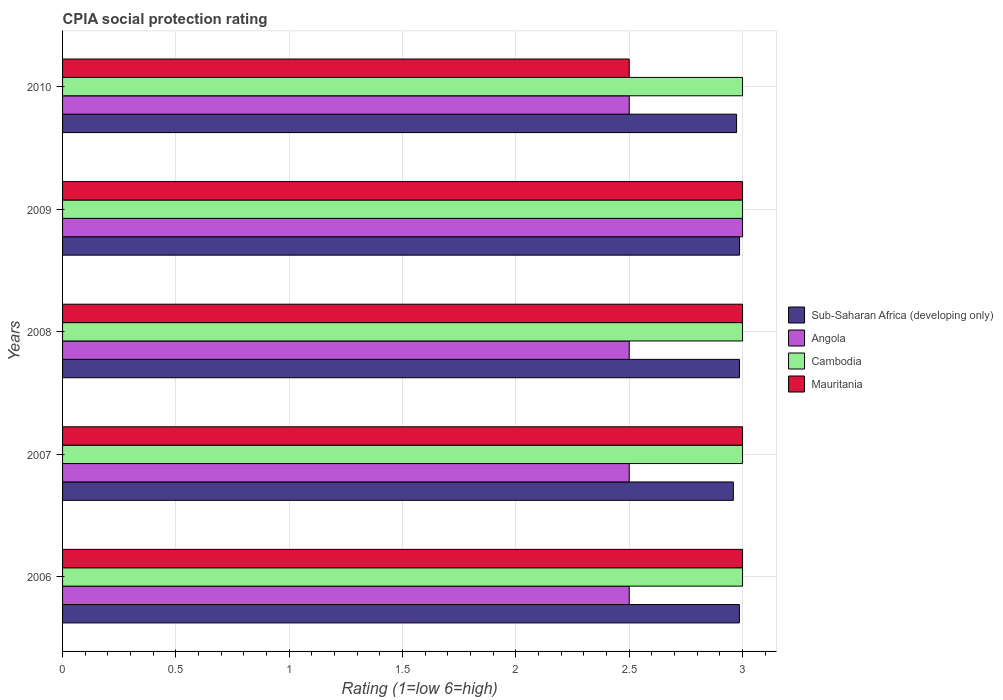Are the number of bars per tick equal to the number of legend labels?
Your answer should be compact. Yes. Are the number of bars on each tick of the Y-axis equal?
Offer a terse response. Yes. How many bars are there on the 2nd tick from the top?
Provide a succinct answer. 4. How many bars are there on the 1st tick from the bottom?
Provide a short and direct response. 4. What is the label of the 2nd group of bars from the top?
Give a very brief answer. 2009. Across all years, what is the maximum CPIA rating in Cambodia?
Your response must be concise. 3. In which year was the CPIA rating in Angola maximum?
Your answer should be compact. 2009. In which year was the CPIA rating in Mauritania minimum?
Your response must be concise. 2010. What is the total CPIA rating in Cambodia in the graph?
Provide a succinct answer. 15. What is the difference between the CPIA rating in Mauritania in 2010 and the CPIA rating in Angola in 2008?
Keep it short and to the point. 0. What is the average CPIA rating in Mauritania per year?
Offer a very short reply. 2.9. In the year 2010, what is the difference between the CPIA rating in Mauritania and CPIA rating in Sub-Saharan Africa (developing only)?
Ensure brevity in your answer.  -0.47. In how many years, is the CPIA rating in Angola greater than 0.6 ?
Offer a terse response. 5. What is the ratio of the CPIA rating in Mauritania in 2006 to that in 2009?
Make the answer very short. 1. Is the difference between the CPIA rating in Mauritania in 2007 and 2009 greater than the difference between the CPIA rating in Sub-Saharan Africa (developing only) in 2007 and 2009?
Provide a succinct answer. Yes. What is the difference between the highest and the second highest CPIA rating in Sub-Saharan Africa (developing only)?
Ensure brevity in your answer.  0. What is the difference between the highest and the lowest CPIA rating in Sub-Saharan Africa (developing only)?
Offer a terse response. 0.03. What does the 1st bar from the top in 2010 represents?
Provide a succinct answer. Mauritania. What does the 2nd bar from the bottom in 2008 represents?
Offer a terse response. Angola. How many bars are there?
Your answer should be compact. 20. Are all the bars in the graph horizontal?
Provide a short and direct response. Yes. Does the graph contain any zero values?
Provide a short and direct response. No. Does the graph contain grids?
Make the answer very short. Yes. Where does the legend appear in the graph?
Give a very brief answer. Center right. What is the title of the graph?
Give a very brief answer. CPIA social protection rating. Does "Uganda" appear as one of the legend labels in the graph?
Offer a very short reply. No. What is the label or title of the X-axis?
Make the answer very short. Rating (1=low 6=high). What is the label or title of the Y-axis?
Offer a terse response. Years. What is the Rating (1=low 6=high) of Sub-Saharan Africa (developing only) in 2006?
Your answer should be very brief. 2.99. What is the Rating (1=low 6=high) in Angola in 2006?
Provide a short and direct response. 2.5. What is the Rating (1=low 6=high) of Sub-Saharan Africa (developing only) in 2007?
Your answer should be compact. 2.96. What is the Rating (1=low 6=high) of Angola in 2007?
Provide a short and direct response. 2.5. What is the Rating (1=low 6=high) in Cambodia in 2007?
Offer a very short reply. 3. What is the Rating (1=low 6=high) of Mauritania in 2007?
Keep it short and to the point. 3. What is the Rating (1=low 6=high) in Sub-Saharan Africa (developing only) in 2008?
Your answer should be very brief. 2.99. What is the Rating (1=low 6=high) of Cambodia in 2008?
Provide a succinct answer. 3. What is the Rating (1=low 6=high) of Mauritania in 2008?
Give a very brief answer. 3. What is the Rating (1=low 6=high) of Sub-Saharan Africa (developing only) in 2009?
Your response must be concise. 2.99. What is the Rating (1=low 6=high) in Angola in 2009?
Your answer should be very brief. 3. What is the Rating (1=low 6=high) in Cambodia in 2009?
Ensure brevity in your answer.  3. What is the Rating (1=low 6=high) of Sub-Saharan Africa (developing only) in 2010?
Your answer should be very brief. 2.97. What is the Rating (1=low 6=high) of Angola in 2010?
Ensure brevity in your answer.  2.5. What is the Rating (1=low 6=high) of Cambodia in 2010?
Ensure brevity in your answer.  3. What is the Rating (1=low 6=high) of Mauritania in 2010?
Provide a succinct answer. 2.5. Across all years, what is the maximum Rating (1=low 6=high) of Sub-Saharan Africa (developing only)?
Offer a very short reply. 2.99. Across all years, what is the maximum Rating (1=low 6=high) of Angola?
Your response must be concise. 3. Across all years, what is the maximum Rating (1=low 6=high) in Cambodia?
Give a very brief answer. 3. Across all years, what is the maximum Rating (1=low 6=high) of Mauritania?
Keep it short and to the point. 3. Across all years, what is the minimum Rating (1=low 6=high) of Sub-Saharan Africa (developing only)?
Provide a succinct answer. 2.96. Across all years, what is the minimum Rating (1=low 6=high) of Cambodia?
Your answer should be very brief. 3. What is the total Rating (1=low 6=high) in Sub-Saharan Africa (developing only) in the graph?
Make the answer very short. 14.89. What is the total Rating (1=low 6=high) in Mauritania in the graph?
Your answer should be compact. 14.5. What is the difference between the Rating (1=low 6=high) of Sub-Saharan Africa (developing only) in 2006 and that in 2007?
Your answer should be compact. 0.03. What is the difference between the Rating (1=low 6=high) of Cambodia in 2006 and that in 2007?
Make the answer very short. 0. What is the difference between the Rating (1=low 6=high) in Sub-Saharan Africa (developing only) in 2006 and that in 2008?
Provide a succinct answer. -0. What is the difference between the Rating (1=low 6=high) of Sub-Saharan Africa (developing only) in 2006 and that in 2009?
Ensure brevity in your answer.  -0. What is the difference between the Rating (1=low 6=high) in Angola in 2006 and that in 2009?
Offer a terse response. -0.5. What is the difference between the Rating (1=low 6=high) in Sub-Saharan Africa (developing only) in 2006 and that in 2010?
Give a very brief answer. 0.01. What is the difference between the Rating (1=low 6=high) of Sub-Saharan Africa (developing only) in 2007 and that in 2008?
Keep it short and to the point. -0.03. What is the difference between the Rating (1=low 6=high) of Angola in 2007 and that in 2008?
Your answer should be very brief. 0. What is the difference between the Rating (1=low 6=high) in Sub-Saharan Africa (developing only) in 2007 and that in 2009?
Provide a short and direct response. -0.03. What is the difference between the Rating (1=low 6=high) of Angola in 2007 and that in 2009?
Give a very brief answer. -0.5. What is the difference between the Rating (1=low 6=high) of Cambodia in 2007 and that in 2009?
Provide a succinct answer. 0. What is the difference between the Rating (1=low 6=high) of Sub-Saharan Africa (developing only) in 2007 and that in 2010?
Keep it short and to the point. -0.01. What is the difference between the Rating (1=low 6=high) in Angola in 2007 and that in 2010?
Offer a very short reply. 0. What is the difference between the Rating (1=low 6=high) in Sub-Saharan Africa (developing only) in 2008 and that in 2009?
Give a very brief answer. -0. What is the difference between the Rating (1=low 6=high) of Cambodia in 2008 and that in 2009?
Provide a succinct answer. 0. What is the difference between the Rating (1=low 6=high) of Mauritania in 2008 and that in 2009?
Ensure brevity in your answer.  0. What is the difference between the Rating (1=low 6=high) of Sub-Saharan Africa (developing only) in 2008 and that in 2010?
Offer a very short reply. 0.01. What is the difference between the Rating (1=low 6=high) of Angola in 2008 and that in 2010?
Offer a terse response. 0. What is the difference between the Rating (1=low 6=high) in Cambodia in 2008 and that in 2010?
Offer a terse response. 0. What is the difference between the Rating (1=low 6=high) of Sub-Saharan Africa (developing only) in 2009 and that in 2010?
Your answer should be very brief. 0.01. What is the difference between the Rating (1=low 6=high) of Cambodia in 2009 and that in 2010?
Your answer should be compact. 0. What is the difference between the Rating (1=low 6=high) of Mauritania in 2009 and that in 2010?
Keep it short and to the point. 0.5. What is the difference between the Rating (1=low 6=high) in Sub-Saharan Africa (developing only) in 2006 and the Rating (1=low 6=high) in Angola in 2007?
Make the answer very short. 0.49. What is the difference between the Rating (1=low 6=high) in Sub-Saharan Africa (developing only) in 2006 and the Rating (1=low 6=high) in Cambodia in 2007?
Keep it short and to the point. -0.01. What is the difference between the Rating (1=low 6=high) of Sub-Saharan Africa (developing only) in 2006 and the Rating (1=low 6=high) of Mauritania in 2007?
Provide a short and direct response. -0.01. What is the difference between the Rating (1=low 6=high) in Angola in 2006 and the Rating (1=low 6=high) in Cambodia in 2007?
Ensure brevity in your answer.  -0.5. What is the difference between the Rating (1=low 6=high) of Sub-Saharan Africa (developing only) in 2006 and the Rating (1=low 6=high) of Angola in 2008?
Your answer should be very brief. 0.49. What is the difference between the Rating (1=low 6=high) of Sub-Saharan Africa (developing only) in 2006 and the Rating (1=low 6=high) of Cambodia in 2008?
Offer a very short reply. -0.01. What is the difference between the Rating (1=low 6=high) of Sub-Saharan Africa (developing only) in 2006 and the Rating (1=low 6=high) of Mauritania in 2008?
Provide a short and direct response. -0.01. What is the difference between the Rating (1=low 6=high) in Angola in 2006 and the Rating (1=low 6=high) in Cambodia in 2008?
Offer a terse response. -0.5. What is the difference between the Rating (1=low 6=high) in Angola in 2006 and the Rating (1=low 6=high) in Mauritania in 2008?
Give a very brief answer. -0.5. What is the difference between the Rating (1=low 6=high) of Cambodia in 2006 and the Rating (1=low 6=high) of Mauritania in 2008?
Your response must be concise. 0. What is the difference between the Rating (1=low 6=high) in Sub-Saharan Africa (developing only) in 2006 and the Rating (1=low 6=high) in Angola in 2009?
Provide a succinct answer. -0.01. What is the difference between the Rating (1=low 6=high) in Sub-Saharan Africa (developing only) in 2006 and the Rating (1=low 6=high) in Cambodia in 2009?
Keep it short and to the point. -0.01. What is the difference between the Rating (1=low 6=high) in Sub-Saharan Africa (developing only) in 2006 and the Rating (1=low 6=high) in Mauritania in 2009?
Provide a short and direct response. -0.01. What is the difference between the Rating (1=low 6=high) in Angola in 2006 and the Rating (1=low 6=high) in Cambodia in 2009?
Your answer should be compact. -0.5. What is the difference between the Rating (1=low 6=high) of Sub-Saharan Africa (developing only) in 2006 and the Rating (1=low 6=high) of Angola in 2010?
Give a very brief answer. 0.49. What is the difference between the Rating (1=low 6=high) of Sub-Saharan Africa (developing only) in 2006 and the Rating (1=low 6=high) of Cambodia in 2010?
Provide a succinct answer. -0.01. What is the difference between the Rating (1=low 6=high) of Sub-Saharan Africa (developing only) in 2006 and the Rating (1=low 6=high) of Mauritania in 2010?
Offer a terse response. 0.49. What is the difference between the Rating (1=low 6=high) in Angola in 2006 and the Rating (1=low 6=high) in Mauritania in 2010?
Offer a very short reply. 0. What is the difference between the Rating (1=low 6=high) of Sub-Saharan Africa (developing only) in 2007 and the Rating (1=low 6=high) of Angola in 2008?
Your response must be concise. 0.46. What is the difference between the Rating (1=low 6=high) of Sub-Saharan Africa (developing only) in 2007 and the Rating (1=low 6=high) of Cambodia in 2008?
Your answer should be compact. -0.04. What is the difference between the Rating (1=low 6=high) in Sub-Saharan Africa (developing only) in 2007 and the Rating (1=low 6=high) in Mauritania in 2008?
Offer a very short reply. -0.04. What is the difference between the Rating (1=low 6=high) in Cambodia in 2007 and the Rating (1=low 6=high) in Mauritania in 2008?
Ensure brevity in your answer.  0. What is the difference between the Rating (1=low 6=high) in Sub-Saharan Africa (developing only) in 2007 and the Rating (1=low 6=high) in Angola in 2009?
Keep it short and to the point. -0.04. What is the difference between the Rating (1=low 6=high) of Sub-Saharan Africa (developing only) in 2007 and the Rating (1=low 6=high) of Cambodia in 2009?
Your answer should be compact. -0.04. What is the difference between the Rating (1=low 6=high) of Sub-Saharan Africa (developing only) in 2007 and the Rating (1=low 6=high) of Mauritania in 2009?
Keep it short and to the point. -0.04. What is the difference between the Rating (1=low 6=high) of Angola in 2007 and the Rating (1=low 6=high) of Cambodia in 2009?
Keep it short and to the point. -0.5. What is the difference between the Rating (1=low 6=high) in Cambodia in 2007 and the Rating (1=low 6=high) in Mauritania in 2009?
Make the answer very short. 0. What is the difference between the Rating (1=low 6=high) in Sub-Saharan Africa (developing only) in 2007 and the Rating (1=low 6=high) in Angola in 2010?
Offer a terse response. 0.46. What is the difference between the Rating (1=low 6=high) of Sub-Saharan Africa (developing only) in 2007 and the Rating (1=low 6=high) of Cambodia in 2010?
Your answer should be compact. -0.04. What is the difference between the Rating (1=low 6=high) of Sub-Saharan Africa (developing only) in 2007 and the Rating (1=low 6=high) of Mauritania in 2010?
Provide a short and direct response. 0.46. What is the difference between the Rating (1=low 6=high) of Angola in 2007 and the Rating (1=low 6=high) of Mauritania in 2010?
Offer a terse response. 0. What is the difference between the Rating (1=low 6=high) in Sub-Saharan Africa (developing only) in 2008 and the Rating (1=low 6=high) in Angola in 2009?
Give a very brief answer. -0.01. What is the difference between the Rating (1=low 6=high) in Sub-Saharan Africa (developing only) in 2008 and the Rating (1=low 6=high) in Cambodia in 2009?
Offer a very short reply. -0.01. What is the difference between the Rating (1=low 6=high) in Sub-Saharan Africa (developing only) in 2008 and the Rating (1=low 6=high) in Mauritania in 2009?
Offer a terse response. -0.01. What is the difference between the Rating (1=low 6=high) in Angola in 2008 and the Rating (1=low 6=high) in Cambodia in 2009?
Keep it short and to the point. -0.5. What is the difference between the Rating (1=low 6=high) in Angola in 2008 and the Rating (1=low 6=high) in Mauritania in 2009?
Your answer should be compact. -0.5. What is the difference between the Rating (1=low 6=high) in Cambodia in 2008 and the Rating (1=low 6=high) in Mauritania in 2009?
Ensure brevity in your answer.  0. What is the difference between the Rating (1=low 6=high) of Sub-Saharan Africa (developing only) in 2008 and the Rating (1=low 6=high) of Angola in 2010?
Provide a succinct answer. 0.49. What is the difference between the Rating (1=low 6=high) of Sub-Saharan Africa (developing only) in 2008 and the Rating (1=low 6=high) of Cambodia in 2010?
Make the answer very short. -0.01. What is the difference between the Rating (1=low 6=high) in Sub-Saharan Africa (developing only) in 2008 and the Rating (1=low 6=high) in Mauritania in 2010?
Provide a succinct answer. 0.49. What is the difference between the Rating (1=low 6=high) in Angola in 2008 and the Rating (1=low 6=high) in Cambodia in 2010?
Your answer should be very brief. -0.5. What is the difference between the Rating (1=low 6=high) in Cambodia in 2008 and the Rating (1=low 6=high) in Mauritania in 2010?
Ensure brevity in your answer.  0.5. What is the difference between the Rating (1=low 6=high) in Sub-Saharan Africa (developing only) in 2009 and the Rating (1=low 6=high) in Angola in 2010?
Your answer should be compact. 0.49. What is the difference between the Rating (1=low 6=high) in Sub-Saharan Africa (developing only) in 2009 and the Rating (1=low 6=high) in Cambodia in 2010?
Your response must be concise. -0.01. What is the difference between the Rating (1=low 6=high) of Sub-Saharan Africa (developing only) in 2009 and the Rating (1=low 6=high) of Mauritania in 2010?
Offer a terse response. 0.49. What is the difference between the Rating (1=low 6=high) in Angola in 2009 and the Rating (1=low 6=high) in Cambodia in 2010?
Your answer should be very brief. 0. What is the average Rating (1=low 6=high) in Sub-Saharan Africa (developing only) per year?
Offer a terse response. 2.98. What is the average Rating (1=low 6=high) in Angola per year?
Offer a very short reply. 2.6. What is the average Rating (1=low 6=high) of Mauritania per year?
Keep it short and to the point. 2.9. In the year 2006, what is the difference between the Rating (1=low 6=high) in Sub-Saharan Africa (developing only) and Rating (1=low 6=high) in Angola?
Your answer should be very brief. 0.49. In the year 2006, what is the difference between the Rating (1=low 6=high) of Sub-Saharan Africa (developing only) and Rating (1=low 6=high) of Cambodia?
Give a very brief answer. -0.01. In the year 2006, what is the difference between the Rating (1=low 6=high) of Sub-Saharan Africa (developing only) and Rating (1=low 6=high) of Mauritania?
Provide a short and direct response. -0.01. In the year 2006, what is the difference between the Rating (1=low 6=high) in Angola and Rating (1=low 6=high) in Cambodia?
Give a very brief answer. -0.5. In the year 2007, what is the difference between the Rating (1=low 6=high) of Sub-Saharan Africa (developing only) and Rating (1=low 6=high) of Angola?
Make the answer very short. 0.46. In the year 2007, what is the difference between the Rating (1=low 6=high) in Sub-Saharan Africa (developing only) and Rating (1=low 6=high) in Cambodia?
Offer a very short reply. -0.04. In the year 2007, what is the difference between the Rating (1=low 6=high) of Sub-Saharan Africa (developing only) and Rating (1=low 6=high) of Mauritania?
Make the answer very short. -0.04. In the year 2007, what is the difference between the Rating (1=low 6=high) of Angola and Rating (1=low 6=high) of Cambodia?
Keep it short and to the point. -0.5. In the year 2007, what is the difference between the Rating (1=low 6=high) of Angola and Rating (1=low 6=high) of Mauritania?
Provide a succinct answer. -0.5. In the year 2007, what is the difference between the Rating (1=low 6=high) of Cambodia and Rating (1=low 6=high) of Mauritania?
Your answer should be compact. 0. In the year 2008, what is the difference between the Rating (1=low 6=high) of Sub-Saharan Africa (developing only) and Rating (1=low 6=high) of Angola?
Provide a succinct answer. 0.49. In the year 2008, what is the difference between the Rating (1=low 6=high) in Sub-Saharan Africa (developing only) and Rating (1=low 6=high) in Cambodia?
Offer a very short reply. -0.01. In the year 2008, what is the difference between the Rating (1=low 6=high) in Sub-Saharan Africa (developing only) and Rating (1=low 6=high) in Mauritania?
Make the answer very short. -0.01. In the year 2008, what is the difference between the Rating (1=low 6=high) of Cambodia and Rating (1=low 6=high) of Mauritania?
Make the answer very short. 0. In the year 2009, what is the difference between the Rating (1=low 6=high) of Sub-Saharan Africa (developing only) and Rating (1=low 6=high) of Angola?
Offer a terse response. -0.01. In the year 2009, what is the difference between the Rating (1=low 6=high) in Sub-Saharan Africa (developing only) and Rating (1=low 6=high) in Cambodia?
Make the answer very short. -0.01. In the year 2009, what is the difference between the Rating (1=low 6=high) of Sub-Saharan Africa (developing only) and Rating (1=low 6=high) of Mauritania?
Keep it short and to the point. -0.01. In the year 2009, what is the difference between the Rating (1=low 6=high) in Angola and Rating (1=low 6=high) in Mauritania?
Offer a terse response. 0. In the year 2010, what is the difference between the Rating (1=low 6=high) in Sub-Saharan Africa (developing only) and Rating (1=low 6=high) in Angola?
Provide a succinct answer. 0.47. In the year 2010, what is the difference between the Rating (1=low 6=high) in Sub-Saharan Africa (developing only) and Rating (1=low 6=high) in Cambodia?
Your answer should be compact. -0.03. In the year 2010, what is the difference between the Rating (1=low 6=high) in Sub-Saharan Africa (developing only) and Rating (1=low 6=high) in Mauritania?
Offer a very short reply. 0.47. What is the ratio of the Rating (1=low 6=high) of Sub-Saharan Africa (developing only) in 2006 to that in 2007?
Ensure brevity in your answer.  1.01. What is the ratio of the Rating (1=low 6=high) of Angola in 2006 to that in 2007?
Provide a succinct answer. 1. What is the ratio of the Rating (1=low 6=high) of Mauritania in 2006 to that in 2007?
Make the answer very short. 1. What is the ratio of the Rating (1=low 6=high) in Angola in 2006 to that in 2008?
Your answer should be compact. 1. What is the ratio of the Rating (1=low 6=high) of Mauritania in 2006 to that in 2008?
Your answer should be very brief. 1. What is the ratio of the Rating (1=low 6=high) of Sub-Saharan Africa (developing only) in 2006 to that in 2009?
Keep it short and to the point. 1. What is the ratio of the Rating (1=low 6=high) of Mauritania in 2006 to that in 2009?
Make the answer very short. 1. What is the ratio of the Rating (1=low 6=high) in Sub-Saharan Africa (developing only) in 2006 to that in 2010?
Provide a succinct answer. 1. What is the ratio of the Rating (1=low 6=high) in Angola in 2006 to that in 2010?
Your answer should be very brief. 1. What is the ratio of the Rating (1=low 6=high) in Cambodia in 2006 to that in 2010?
Your answer should be very brief. 1. What is the ratio of the Rating (1=low 6=high) in Mauritania in 2006 to that in 2010?
Your answer should be compact. 1.2. What is the ratio of the Rating (1=low 6=high) of Sub-Saharan Africa (developing only) in 2007 to that in 2008?
Offer a very short reply. 0.99. What is the ratio of the Rating (1=low 6=high) of Cambodia in 2007 to that in 2008?
Make the answer very short. 1. What is the ratio of the Rating (1=low 6=high) of Mauritania in 2007 to that in 2009?
Provide a short and direct response. 1. What is the ratio of the Rating (1=low 6=high) in Sub-Saharan Africa (developing only) in 2007 to that in 2010?
Provide a short and direct response. 1. What is the ratio of the Rating (1=low 6=high) of Angola in 2007 to that in 2010?
Ensure brevity in your answer.  1. What is the ratio of the Rating (1=low 6=high) in Cambodia in 2007 to that in 2010?
Your response must be concise. 1. What is the ratio of the Rating (1=low 6=high) in Sub-Saharan Africa (developing only) in 2008 to that in 2010?
Give a very brief answer. 1. What is the ratio of the Rating (1=low 6=high) in Sub-Saharan Africa (developing only) in 2009 to that in 2010?
Provide a succinct answer. 1. What is the ratio of the Rating (1=low 6=high) in Angola in 2009 to that in 2010?
Offer a very short reply. 1.2. What is the ratio of the Rating (1=low 6=high) of Cambodia in 2009 to that in 2010?
Make the answer very short. 1. What is the ratio of the Rating (1=low 6=high) of Mauritania in 2009 to that in 2010?
Provide a succinct answer. 1.2. What is the difference between the highest and the second highest Rating (1=low 6=high) of Sub-Saharan Africa (developing only)?
Provide a short and direct response. 0. What is the difference between the highest and the second highest Rating (1=low 6=high) in Angola?
Offer a terse response. 0.5. What is the difference between the highest and the lowest Rating (1=low 6=high) of Sub-Saharan Africa (developing only)?
Your answer should be very brief. 0.03. What is the difference between the highest and the lowest Rating (1=low 6=high) in Cambodia?
Offer a terse response. 0. What is the difference between the highest and the lowest Rating (1=low 6=high) of Mauritania?
Give a very brief answer. 0.5. 